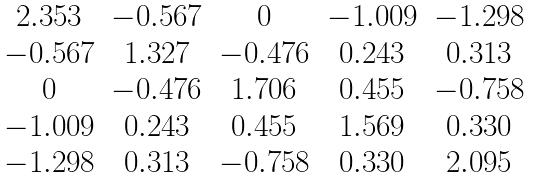Convert formula to latex. <formula><loc_0><loc_0><loc_500><loc_500>\begin{matrix} 2 . 3 5 3 & - 0 . 5 6 7 & 0 & - 1 . 0 0 9 & - 1 . 2 9 8 \\ - 0 . 5 6 7 & 1 . 3 2 7 & - 0 . 4 7 6 & 0 . 2 4 3 & 0 . 3 1 3 \\ 0 & - 0 . 4 7 6 & 1 . 7 0 6 & 0 . 4 5 5 & - 0 . 7 5 8 \\ - 1 . 0 0 9 & 0 . 2 4 3 & 0 . 4 5 5 & 1 . 5 6 9 & 0 . 3 3 0 \\ - 1 . 2 9 8 & 0 . 3 1 3 & - 0 . 7 5 8 & 0 . 3 3 0 & 2 . 0 9 5 \end{matrix}</formula> 